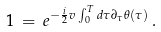<formula> <loc_0><loc_0><loc_500><loc_500>1 \, = \, e ^ { - \frac { i } { 2 } v \int _ { 0 } ^ { T } d \tau \partial _ { \tau } \theta ( \tau ) } \, .</formula> 